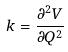Convert formula to latex. <formula><loc_0><loc_0><loc_500><loc_500>k = \frac { \partial ^ { 2 } V } { \partial Q ^ { 2 } }</formula> 